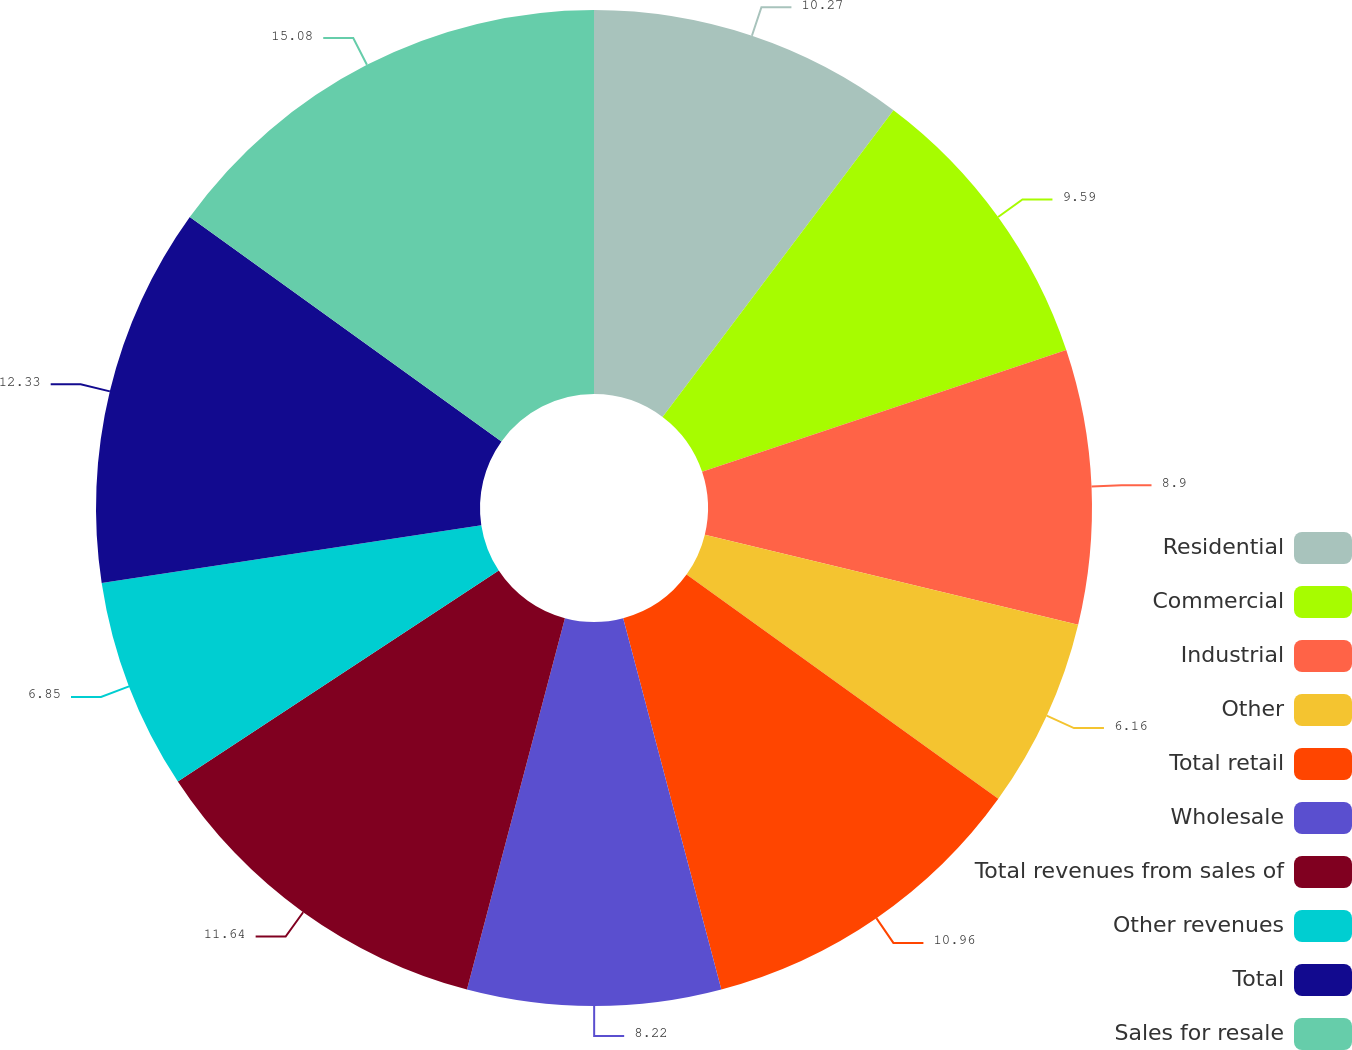Convert chart to OTSL. <chart><loc_0><loc_0><loc_500><loc_500><pie_chart><fcel>Residential<fcel>Commercial<fcel>Industrial<fcel>Other<fcel>Total retail<fcel>Wholesale<fcel>Total revenues from sales of<fcel>Other revenues<fcel>Total<fcel>Sales for resale<nl><fcel>10.27%<fcel>9.59%<fcel>8.9%<fcel>6.16%<fcel>10.96%<fcel>8.22%<fcel>11.64%<fcel>6.85%<fcel>12.33%<fcel>15.07%<nl></chart> 